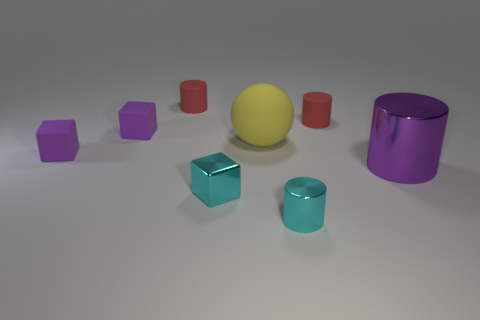Add 1 large brown spheres. How many objects exist? 9 Subtract all cyan cylinders. How many cylinders are left? 3 Subtract all purple cylinders. How many cylinders are left? 3 Subtract 1 cyan cylinders. How many objects are left? 7 Subtract all cubes. How many objects are left? 5 Subtract all cyan balls. Subtract all yellow cubes. How many balls are left? 1 Subtract all brown cylinders. How many purple cubes are left? 2 Subtract all big metal objects. Subtract all big blue cubes. How many objects are left? 7 Add 7 purple matte objects. How many purple matte objects are left? 9 Add 2 purple cubes. How many purple cubes exist? 4 